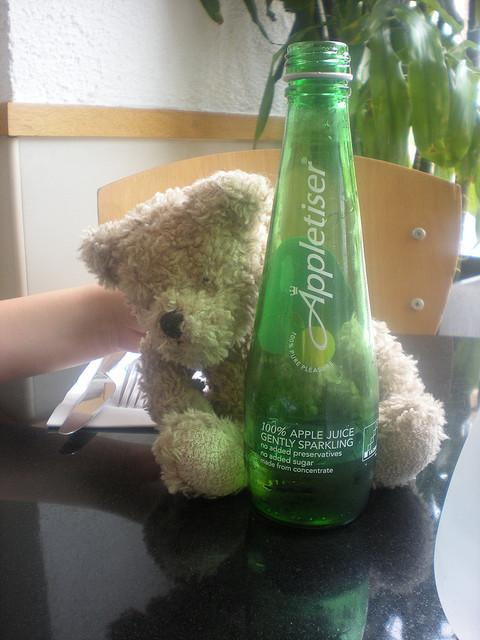What is in the green container?

Choices:
A) juice
B) vinegar
C) wine
D) butter juice 